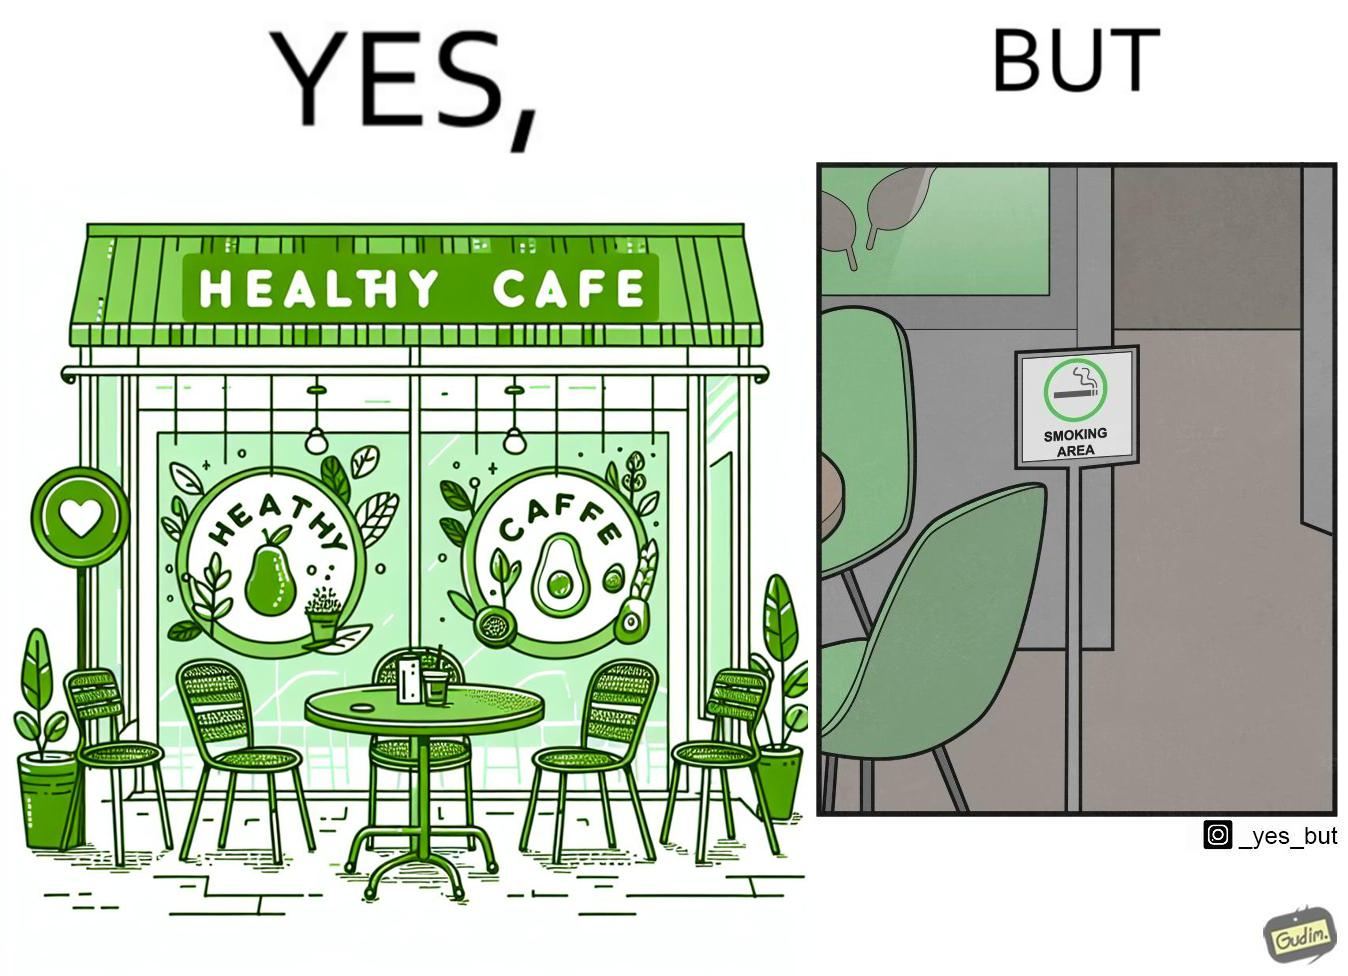Provide a description of this image. This image is funny because an eatery that calls itself the "healthy" cafe also has a smoking area, which is not very "healthy". If it really was a healthy cafe, it would not have a smoking area as smoking is injurious to health. Satire on the behavior of humans - both those that operate this cafe who made the decision of allowing smoking and creating a designated smoking area, and those that visit this healthy cafe to become "healthy", but then also indulge in very unhealthy habits simultaneously. 